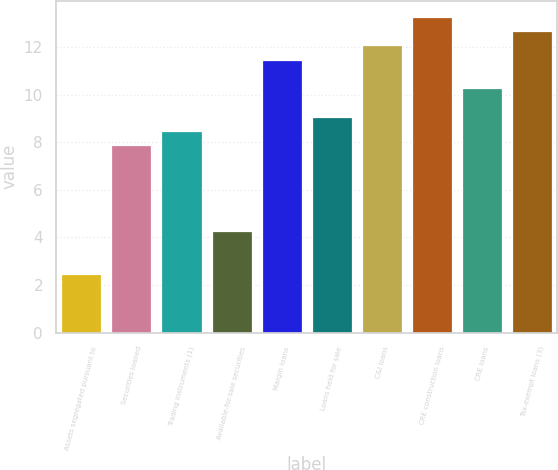<chart> <loc_0><loc_0><loc_500><loc_500><bar_chart><fcel>Assets segregated pursuant to<fcel>Securities loaned<fcel>Trading instruments (1)<fcel>Available-for-sale securities<fcel>Margin loans<fcel>Loans held for sale<fcel>C&I loans<fcel>CRE construction loans<fcel>CRE loans<fcel>Tax-exempt loans (3)<nl><fcel>2.48<fcel>7.88<fcel>8.48<fcel>4.28<fcel>11.48<fcel>9.08<fcel>12.08<fcel>13.28<fcel>10.28<fcel>12.68<nl></chart> 